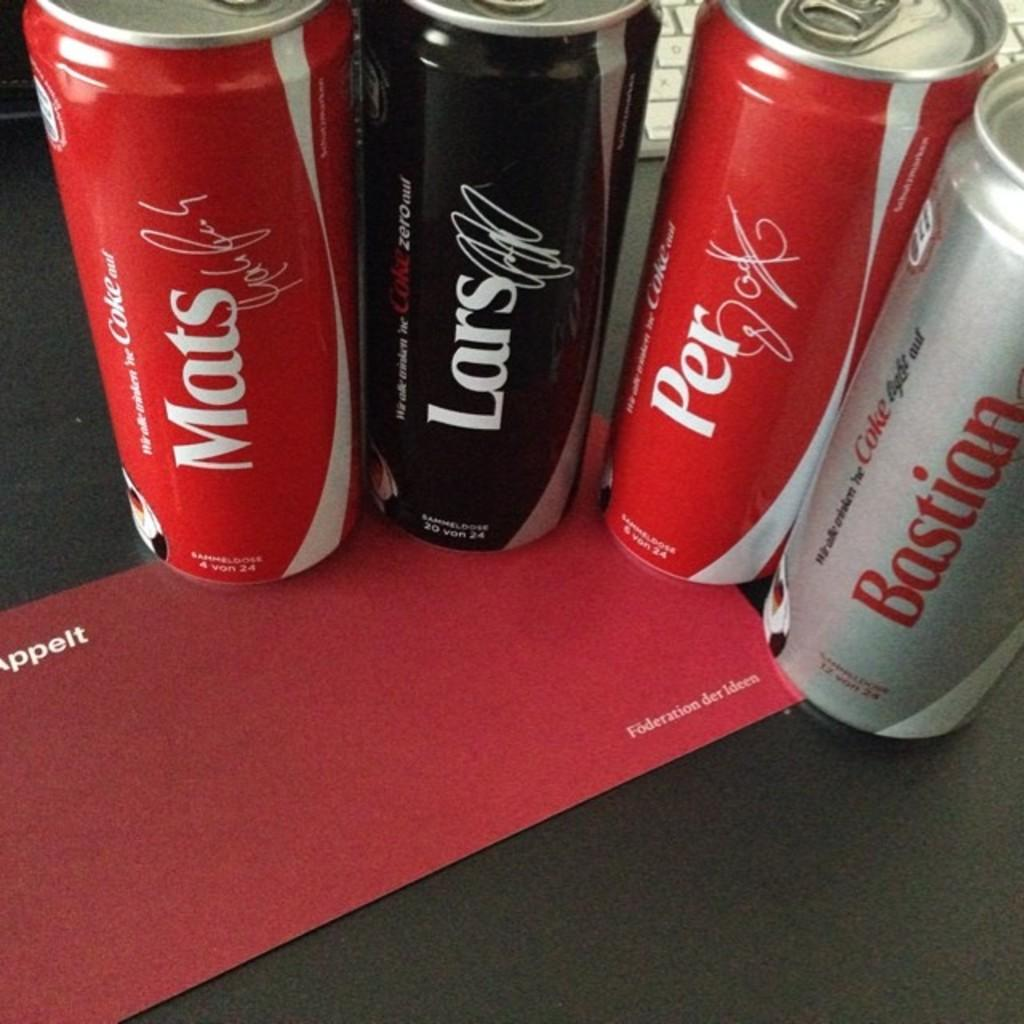<image>
Write a terse but informative summary of the picture. Cans of coke with swedis names on them such  as lars and mats. 